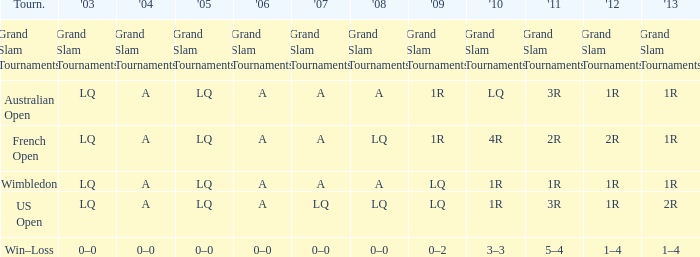Which year has a 2011 of 1r? A. Help me parse the entirety of this table. {'header': ['Tourn.', "'03", "'04", "'05", "'06", "'07", "'08", "'09", "'10", "'11", "'12", "'13"], 'rows': [['Grand Slam Tournaments', 'Grand Slam Tournaments', 'Grand Slam Tournaments', 'Grand Slam Tournaments', 'Grand Slam Tournaments', 'Grand Slam Tournaments', 'Grand Slam Tournaments', 'Grand Slam Tournaments', 'Grand Slam Tournaments', 'Grand Slam Tournaments', 'Grand Slam Tournaments', 'Grand Slam Tournaments'], ['Australian Open', 'LQ', 'A', 'LQ', 'A', 'A', 'A', '1R', 'LQ', '3R', '1R', '1R'], ['French Open', 'LQ', 'A', 'LQ', 'A', 'A', 'LQ', '1R', '4R', '2R', '2R', '1R'], ['Wimbledon', 'LQ', 'A', 'LQ', 'A', 'A', 'A', 'LQ', '1R', '1R', '1R', '1R'], ['US Open', 'LQ', 'A', 'LQ', 'A', 'LQ', 'LQ', 'LQ', '1R', '3R', '1R', '2R'], ['Win–Loss', '0–0', '0–0', '0–0', '0–0', '0–0', '0–0', '0–2', '3–3', '5–4', '1–4', '1–4']]} 